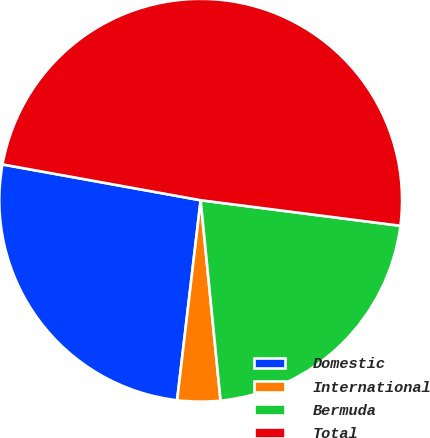<chart> <loc_0><loc_0><loc_500><loc_500><pie_chart><fcel>Domestic<fcel>International<fcel>Bermuda<fcel>Total<nl><fcel>25.98%<fcel>3.44%<fcel>21.4%<fcel>49.18%<nl></chart> 